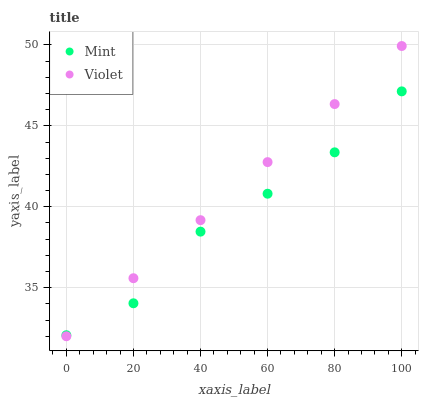Does Mint have the minimum area under the curve?
Answer yes or no. Yes. Does Violet have the maximum area under the curve?
Answer yes or no. Yes. Does Violet have the minimum area under the curve?
Answer yes or no. No. Is Violet the smoothest?
Answer yes or no. Yes. Is Mint the roughest?
Answer yes or no. Yes. Is Violet the roughest?
Answer yes or no. No. Does Violet have the lowest value?
Answer yes or no. Yes. Does Violet have the highest value?
Answer yes or no. Yes. Does Mint intersect Violet?
Answer yes or no. Yes. Is Mint less than Violet?
Answer yes or no. No. Is Mint greater than Violet?
Answer yes or no. No. 